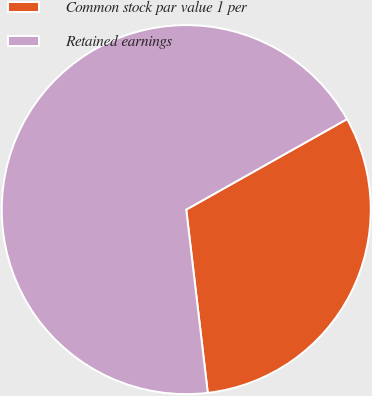<chart> <loc_0><loc_0><loc_500><loc_500><pie_chart><fcel>Common stock par value 1 per<fcel>Retained earnings<nl><fcel>31.3%<fcel>68.7%<nl></chart> 